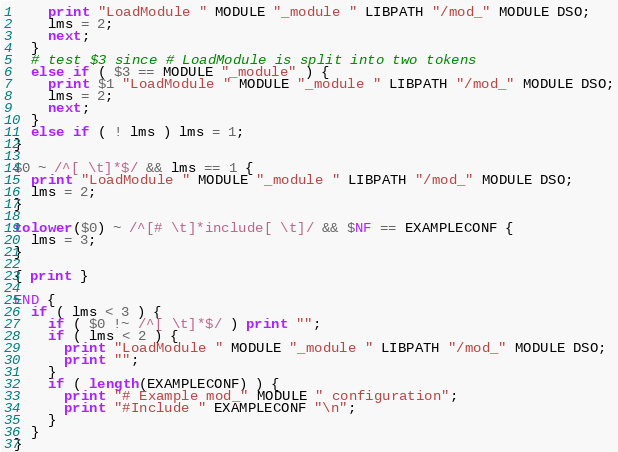<code> <loc_0><loc_0><loc_500><loc_500><_Awk_>    print "LoadModule " MODULE "_module " LIBPATH "/mod_" MODULE DSO;
    lms = 2;
    next;
  }
  # test $3 since # LoadModule is split into two tokens
  else if ( $3 == MODULE "_module" ) {
    print $1 "LoadModule " MODULE "_module " LIBPATH "/mod_" MODULE DSO;
    lms = 2;
    next;
  }
  else if ( ! lms ) lms = 1;
}

$0 ~ /^[ \t]*$/ && lms == 1 {
  print "LoadModule " MODULE "_module " LIBPATH "/mod_" MODULE DSO;
  lms = 2;
} 

tolower($0) ~ /^[# \t]*include[ \t]/ && $NF == EXAMPLECONF {
  lms = 3;
}

{ print }

END {
  if ( lms < 3 ) { 
    if ( $0 !~ /^[ \t]*$/ ) print "";
    if ( lms < 2 ) { 
      print "LoadModule " MODULE "_module " LIBPATH "/mod_" MODULE DSO;
      print "";
    }
    if ( length(EXAMPLECONF) ) {
      print "# Example mod_" MODULE " configuration";
      print "#Include " EXAMPLECONF "\n";
    }
  }
}

</code> 